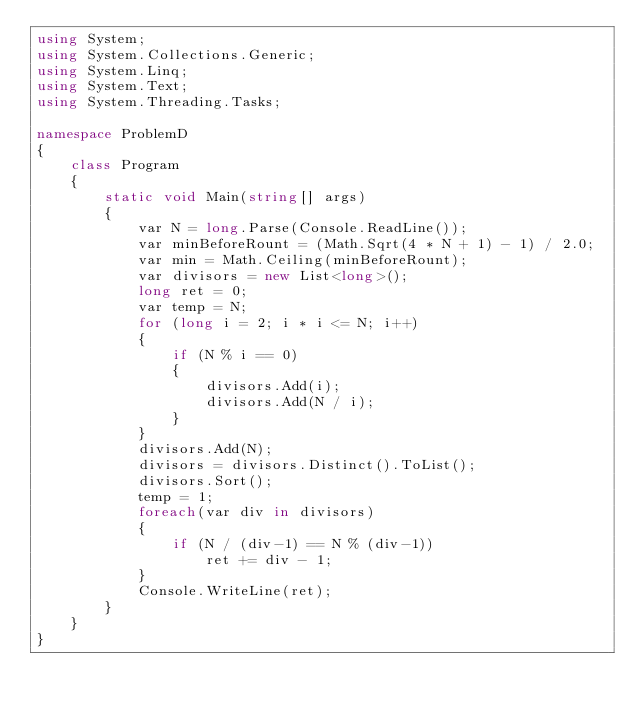Convert code to text. <code><loc_0><loc_0><loc_500><loc_500><_C#_>using System;
using System.Collections.Generic;
using System.Linq;
using System.Text;
using System.Threading.Tasks;

namespace ProblemD
{
    class Program
    {
        static void Main(string[] args)
        {
            var N = long.Parse(Console.ReadLine());
            var minBeforeRount = (Math.Sqrt(4 * N + 1) - 1) / 2.0;
            var min = Math.Ceiling(minBeforeRount);
            var divisors = new List<long>();
            long ret = 0;
            var temp = N;
            for (long i = 2; i * i <= N; i++)
            {
                if (N % i == 0)
                {
                    divisors.Add(i);
                    divisors.Add(N / i);
                }
            }
            divisors.Add(N);
            divisors = divisors.Distinct().ToList();
            divisors.Sort();
            temp = 1;
            foreach(var div in divisors)
            {
                if (N / (div-1) == N % (div-1))
                    ret += div - 1;
            }
            Console.WriteLine(ret);
        }
    }
}
</code> 